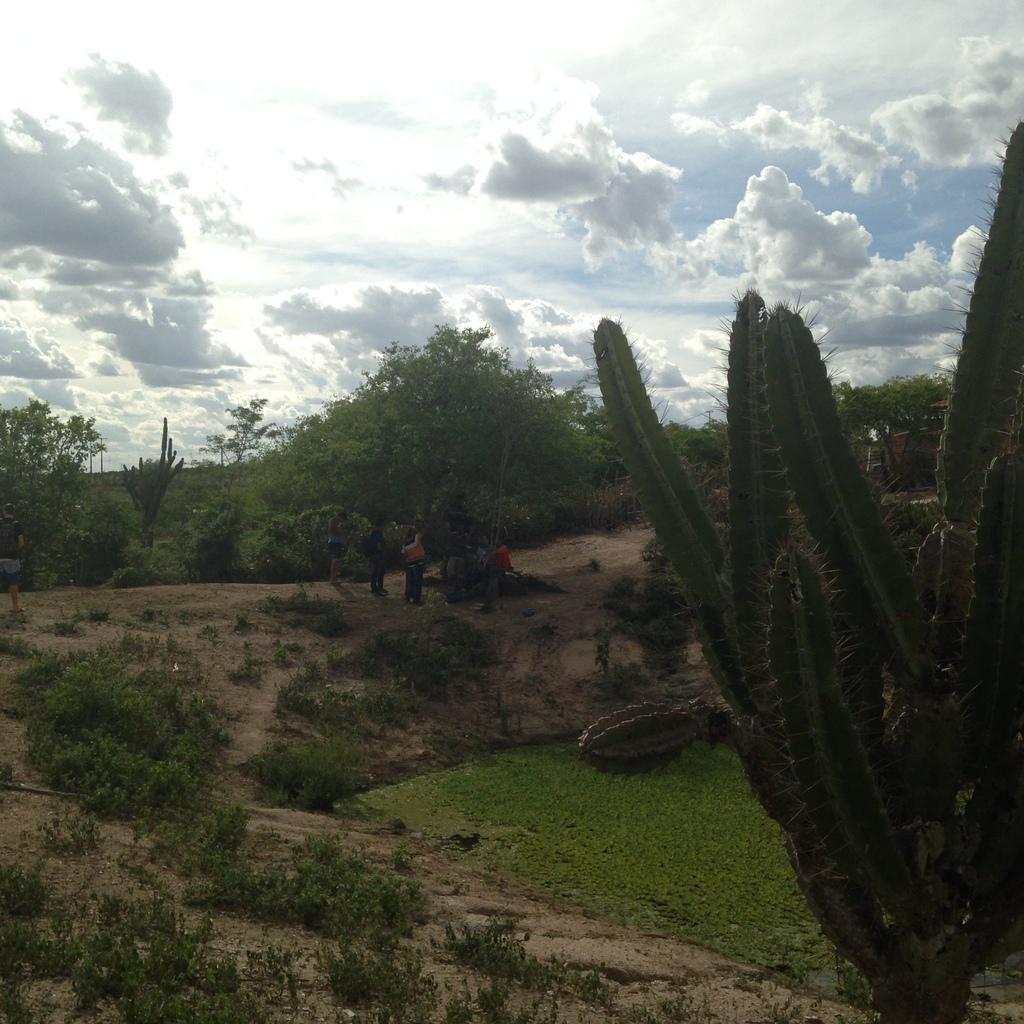Can you describe this image briefly? In this picture I can see some people who are standing near to the tree. In the background I can see many trees, plants and grass. In the bottom right I can see the water. At the top I can see the sky and clouds. 